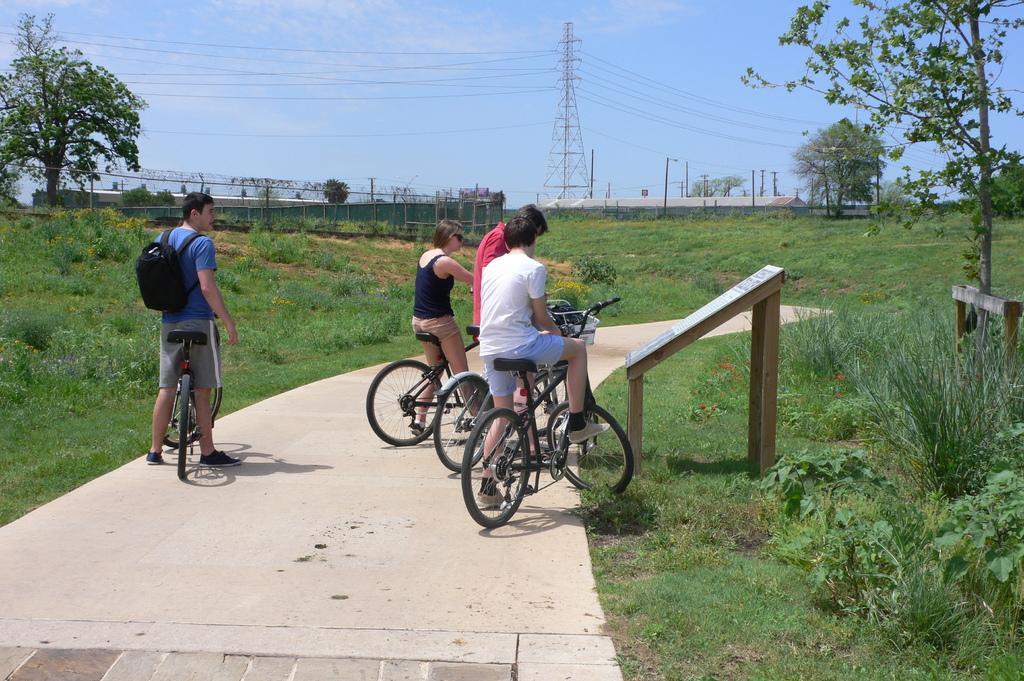Can you describe this image briefly? In this image, there are four people with the bicycles on the pathway. On the right side of the image, I can see a board. There are plants, grass and trees. In the background, I can see the fence, transmission tower, current poles and the sky. 